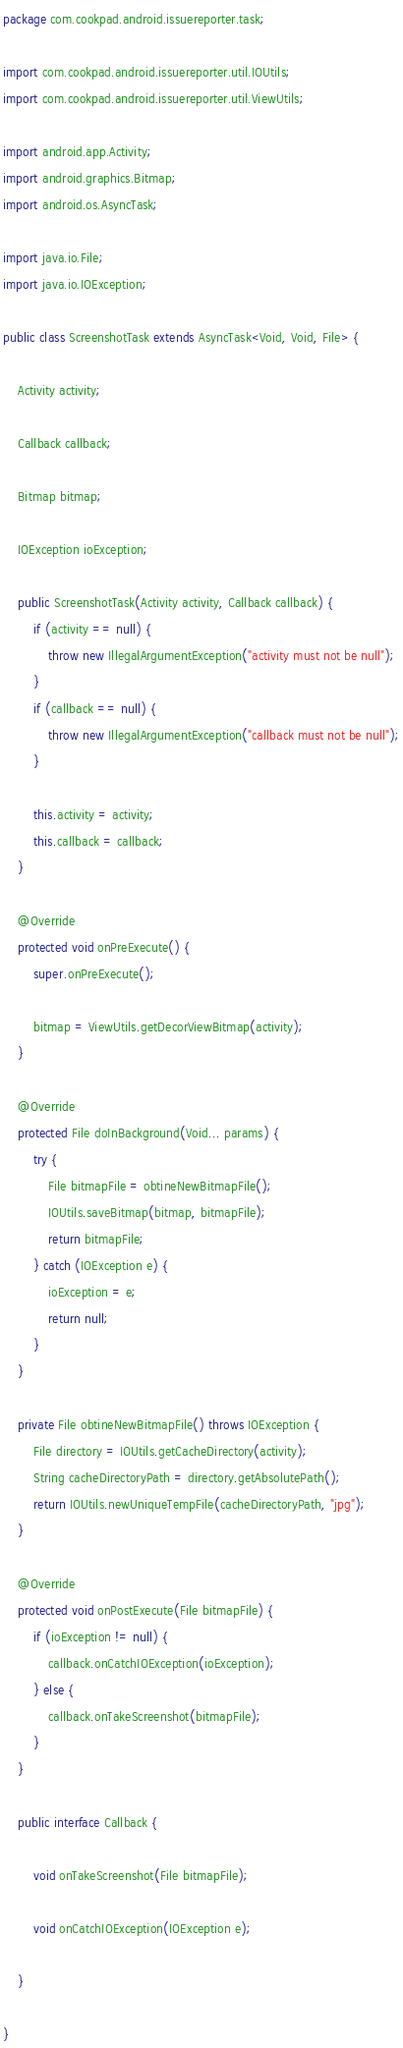Convert code to text. <code><loc_0><loc_0><loc_500><loc_500><_Java_>package com.cookpad.android.issuereporter.task;

import com.cookpad.android.issuereporter.util.IOUtils;
import com.cookpad.android.issuereporter.util.ViewUtils;

import android.app.Activity;
import android.graphics.Bitmap;
import android.os.AsyncTask;

import java.io.File;
import java.io.IOException;

public class ScreenshotTask extends AsyncTask<Void, Void, File> {

    Activity activity;

    Callback callback;

    Bitmap bitmap;

    IOException ioException;

    public ScreenshotTask(Activity activity, Callback callback) {
        if (activity == null) {
            throw new IllegalArgumentException("activity must not be null");
        }
        if (callback == null) {
            throw new IllegalArgumentException("callback must not be null");
        }

        this.activity = activity;
        this.callback = callback;
    }

    @Override
    protected void onPreExecute() {
        super.onPreExecute();

        bitmap = ViewUtils.getDecorViewBitmap(activity);
    }

    @Override
    protected File doInBackground(Void... params) {
        try {
            File bitmapFile = obtineNewBitmapFile();
            IOUtils.saveBitmap(bitmap, bitmapFile);
            return bitmapFile;
        } catch (IOException e) {
            ioException = e;
            return null;
        }
    }

    private File obtineNewBitmapFile() throws IOException {
        File directory = IOUtils.getCacheDirectory(activity);
        String cacheDirectoryPath = directory.getAbsolutePath();
        return IOUtils.newUniqueTempFile(cacheDirectoryPath, "jpg");
    }

    @Override
    protected void onPostExecute(File bitmapFile) {
        if (ioException != null) {
            callback.onCatchIOException(ioException);
        } else {
            callback.onTakeScreenshot(bitmapFile);
        }
    }

    public interface Callback {

        void onTakeScreenshot(File bitmapFile);

        void onCatchIOException(IOException e);

    }

}
</code> 